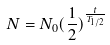Convert formula to latex. <formula><loc_0><loc_0><loc_500><loc_500>N = N _ { 0 } ( \frac { 1 } { 2 } ) ^ { \frac { t } { T _ { 1 / 2 } } }</formula> 